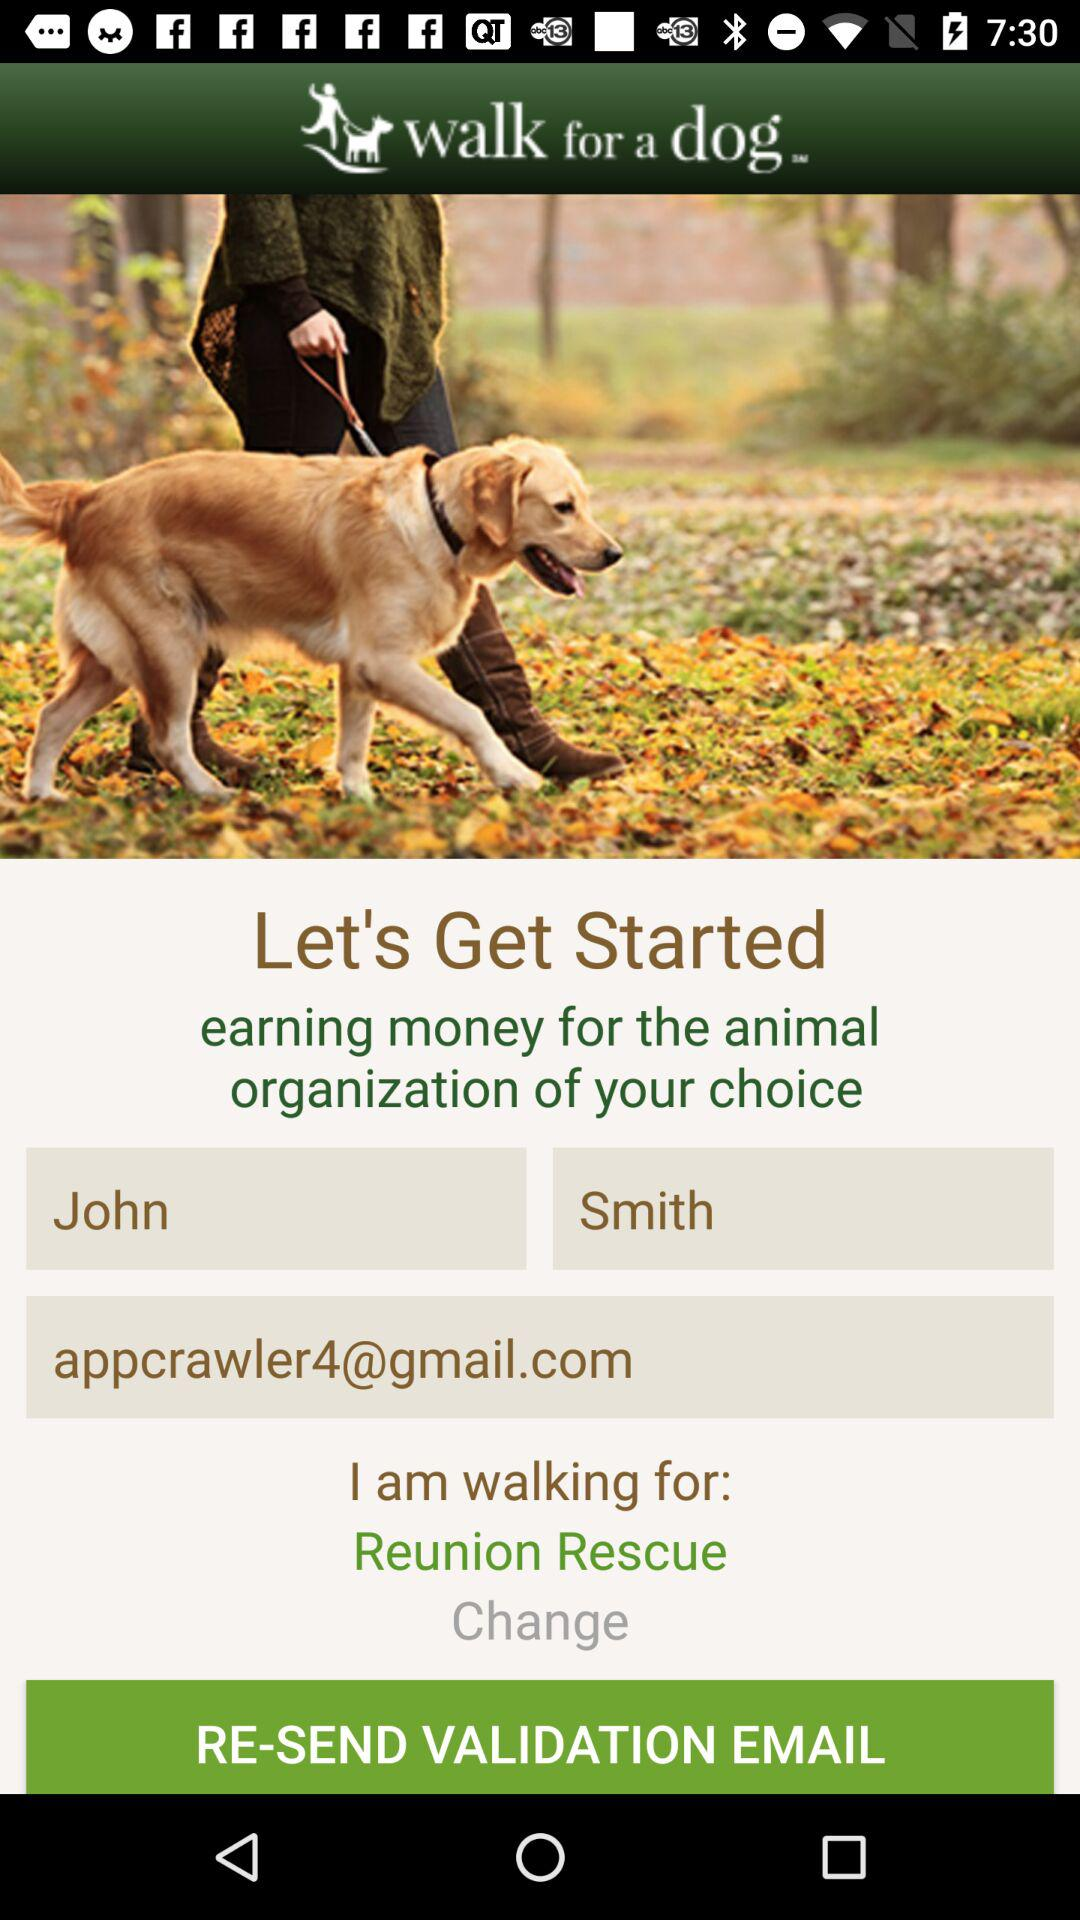What is the name of the animal organization? The name of the organization is "Reunion Rescue". 